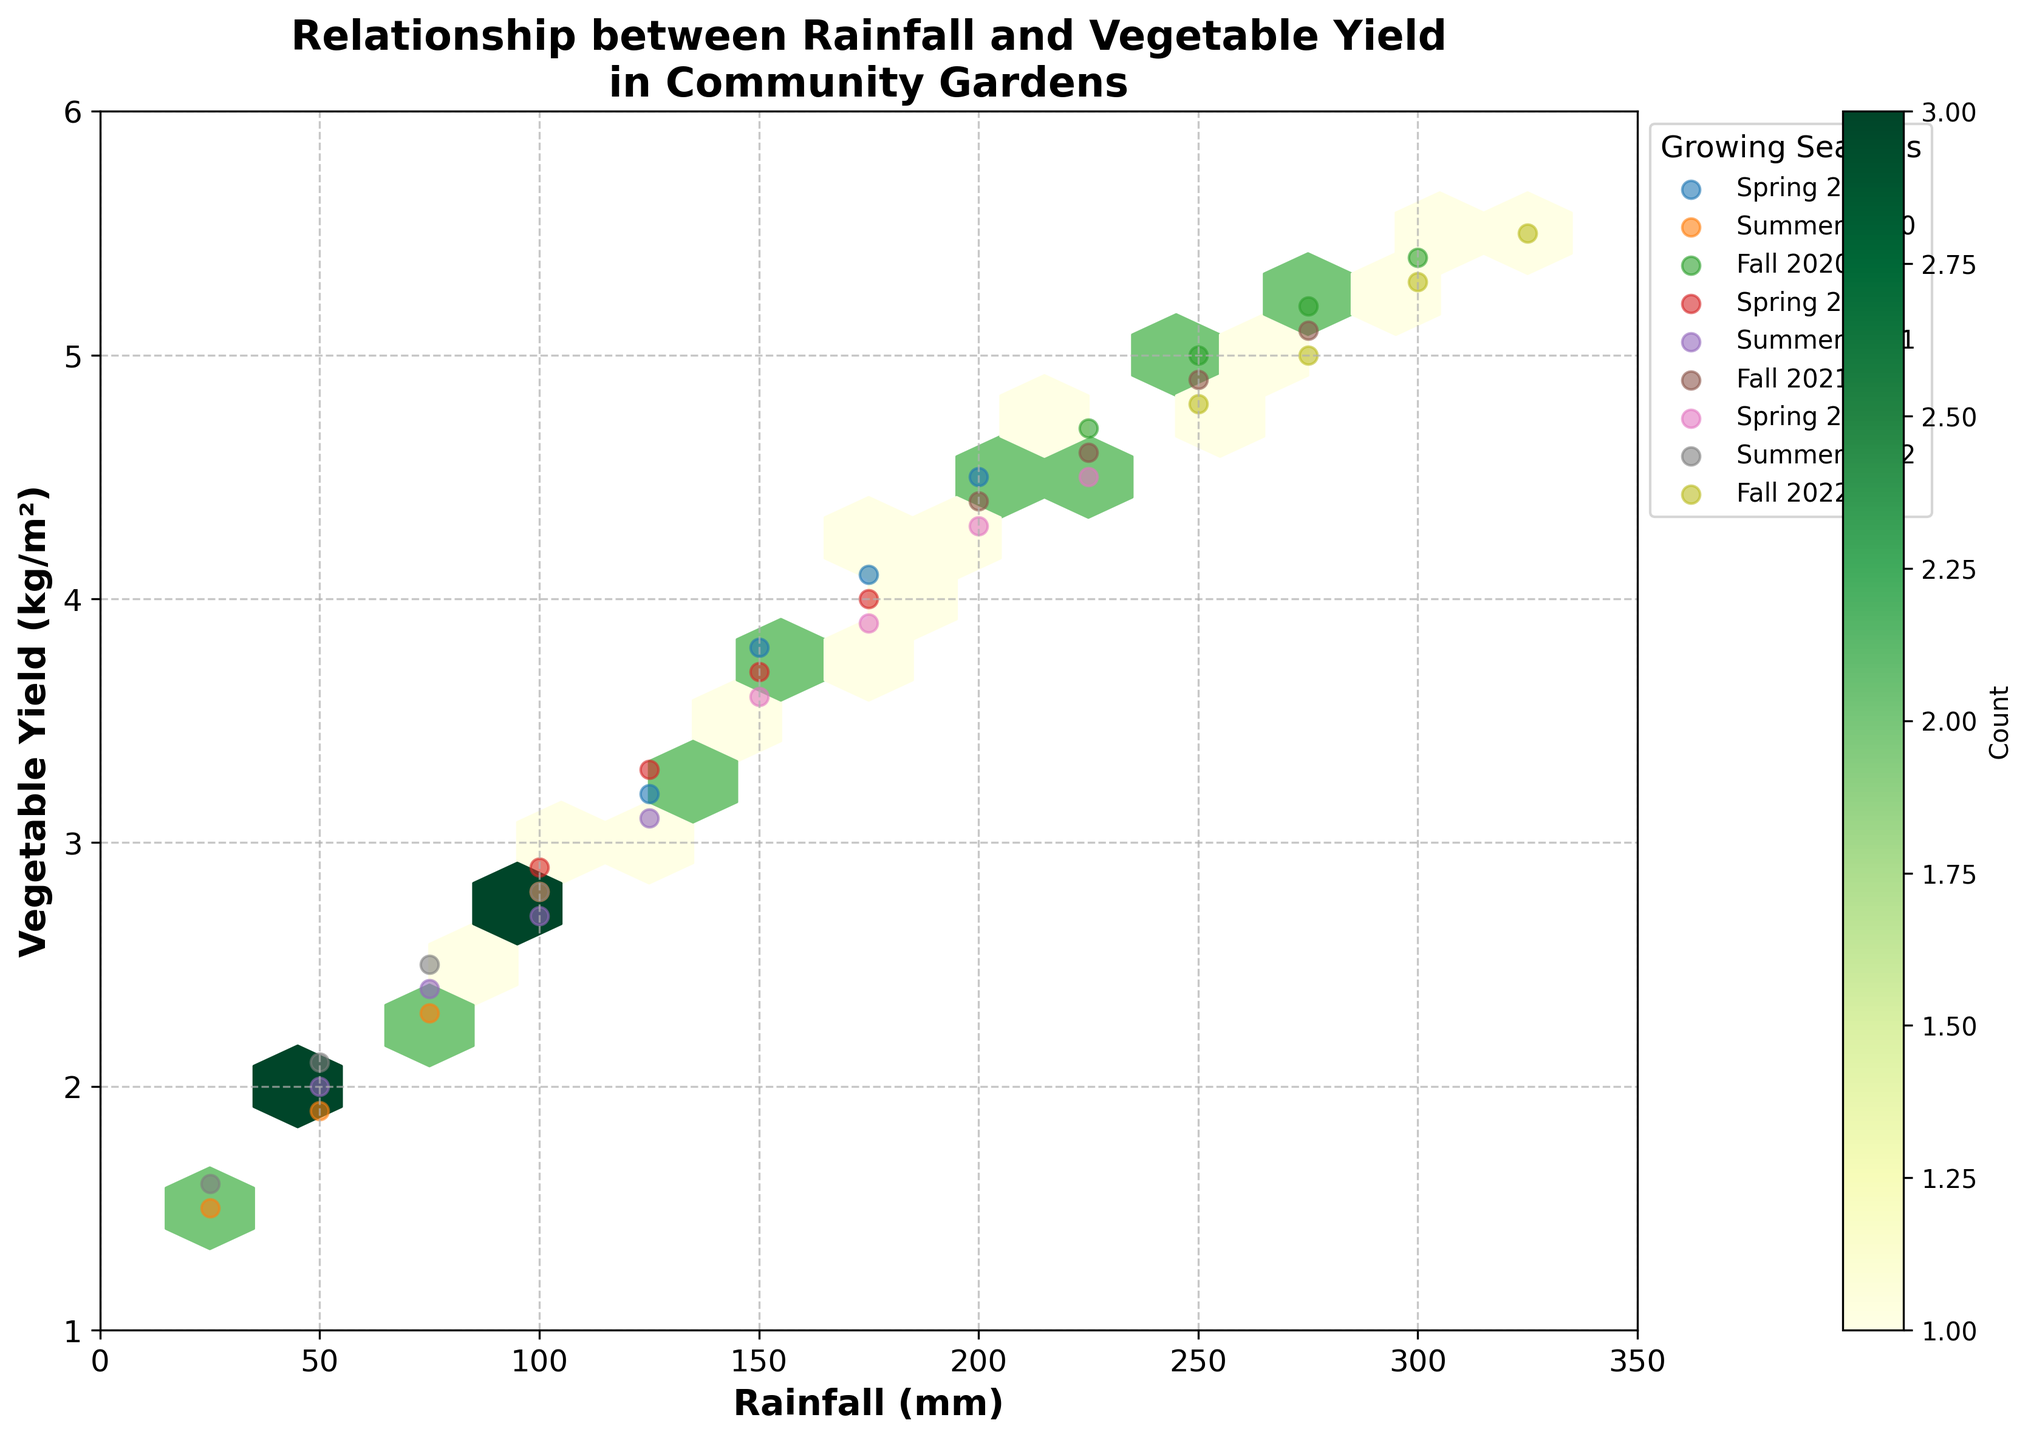What's the title of the hexbin plot? The title is the text displayed at the top of the figure. It can be easily read directly from the plot.
Answer: Relationship between Rainfall and Vegetable Yield in Community Gardens What are the labels of the x-axis and y-axis? The x-axis label is the text along the horizontal axis, and the y-axis label is the text along the vertical axis. It indicates what the axes represent.
Answer: Rainfall (mm) and Vegetable Yield (kg/m²) How is the color intensity in the hexbin plot related to the count of data points in that area? The color intensity in a hexbin plot changes based on the number of data points in a specific area. The higher the count of data points, the darker the color.
Answer: Higher counts have darker colors Which season shows the highest vegetable yield on average based on the plot? By looking at the scattered points for each season in the plot and their corresponding average yield (height on the y-axis), we can determine which season generally has higher yields.
Answer: Fall What is the relationship between rainfall and vegetable yield displayed in the plot? The hexbin plot shows a general trend where an increase in rainfall is associated with an increase in vegetable yield, indicated by the clustering of points from bottom-left to top-right.
Answer: Positive correlation Looking at the scatter points, which season has the least overlap with others in terms of rainfall and vegetable yield? The season with the data points that are most clearly separated from the clusters of other seasons indicates the least overlap. Summer data points are distinctly lower in both rainfall and yield compared to other seasons.
Answer: Summer Which rainfall range appears to produce the most consistent vegetable yields based on the plot? The most consistent yields are represented by a tight cluster of hexagons with the same color intensity within a specific rainfall range, suggesting uniform vegetable production.
Answer: 200-250 mm How does the vegetable yield differ between 100 mm and 300 mm of rainfall? By observing the y-value (vegetable yield) of hexagons and scatter points around the 100 mm and 300 mm rainfall markers, we can compare the yields. Generally, yields are significantly higher at 300 mm compared to 100 mm of rainfall.
Answer: Yields are higher at 300 mm Which fall season exhibited the highest yield based on the plot? By examining the scatter points labeled for different fall seasons and noting the highest points on the y-axis, we can determine which fall had the highest yield.
Answer: Fall 2022 Is there a significant overlap of yield values between Spring and Summer seasons? Comparing the positions of scatter points for Spring and Summer, we can see if there are common areas within the same yield range. The overlap appears minimal, with Summer having generally lower yields.
Answer: Minimal overlap 